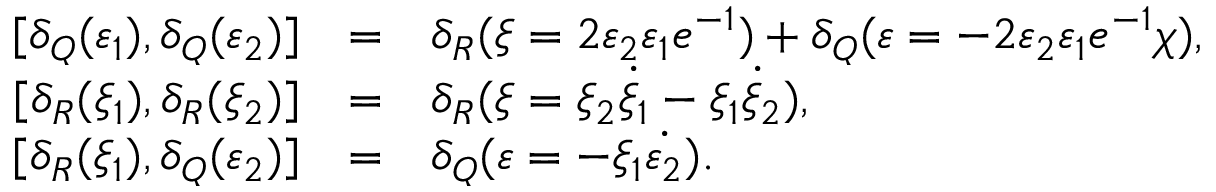Convert formula to latex. <formula><loc_0><loc_0><loc_500><loc_500>\begin{array} { r c l } { { \, [ \delta _ { Q } ( \varepsilon _ { 1 } ) , \delta _ { Q } ( \varepsilon _ { 2 } ) ] } } & { = } & { { \delta _ { R } ( \xi = 2 \varepsilon _ { 2 } \varepsilon _ { 1 } e ^ { - 1 } ) + \delta _ { Q } ( \varepsilon = - 2 \varepsilon _ { 2 } \varepsilon _ { 1 } e ^ { - 1 } \chi ) , } } \\ { { \, [ \delta _ { R } ( \xi _ { 1 } ) , \delta _ { R } ( \xi _ { 2 } ) ] } } & { = } & { { \delta _ { R } ( \xi = \xi _ { 2 } \dot { \xi } _ { 1 } - \xi _ { 1 } \dot { \xi } _ { 2 } ) , } } \\ { { \, [ \delta _ { R } ( \xi _ { 1 } ) , \delta _ { Q } ( \varepsilon _ { 2 } ) ] } } & { = } & { { \delta _ { Q } ( \varepsilon = - \xi _ { 1 } \dot { \varepsilon _ { 2 } } ) . } } \end{array}</formula> 